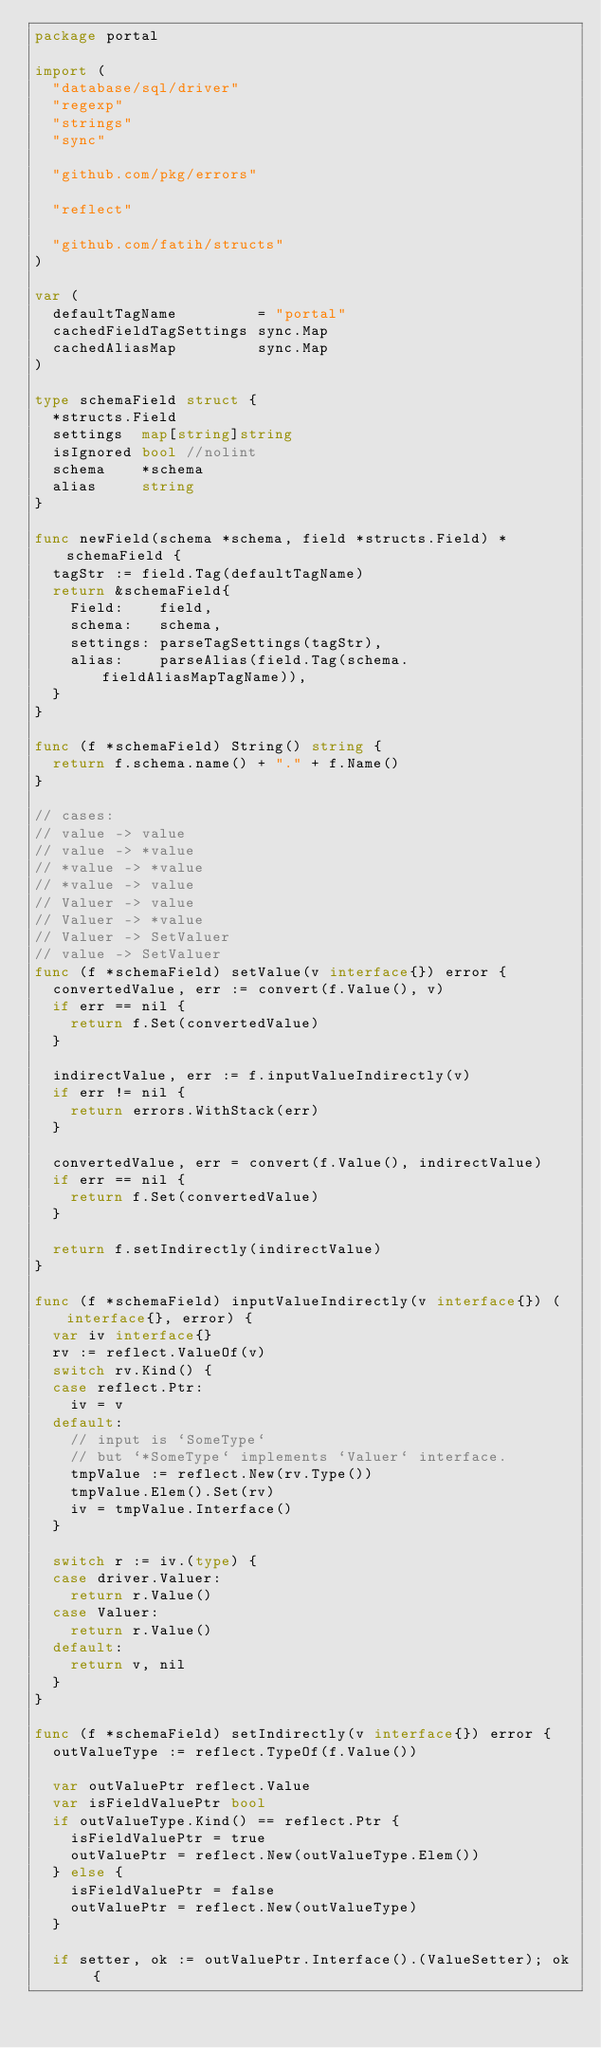<code> <loc_0><loc_0><loc_500><loc_500><_Go_>package portal

import (
	"database/sql/driver"
	"regexp"
	"strings"
	"sync"

	"github.com/pkg/errors"

	"reflect"

	"github.com/fatih/structs"
)

var (
	defaultTagName         = "portal"
	cachedFieldTagSettings sync.Map
	cachedAliasMap         sync.Map
)

type schemaField struct {
	*structs.Field
	settings  map[string]string
	isIgnored bool //nolint
	schema    *schema
	alias     string
}

func newField(schema *schema, field *structs.Field) *schemaField {
	tagStr := field.Tag(defaultTagName)
	return &schemaField{
		Field:    field,
		schema:   schema,
		settings: parseTagSettings(tagStr),
		alias:    parseAlias(field.Tag(schema.fieldAliasMapTagName)),
	}
}

func (f *schemaField) String() string {
	return f.schema.name() + "." + f.Name()
}

// cases:
// value -> value
// value -> *value
// *value -> *value
// *value -> value
// Valuer -> value
// Valuer -> *value
// Valuer -> SetValuer
// value -> SetValuer
func (f *schemaField) setValue(v interface{}) error {
	convertedValue, err := convert(f.Value(), v)
	if err == nil {
		return f.Set(convertedValue)
	}

	indirectValue, err := f.inputValueIndirectly(v)
	if err != nil {
		return errors.WithStack(err)
	}

	convertedValue, err = convert(f.Value(), indirectValue)
	if err == nil {
		return f.Set(convertedValue)
	}

	return f.setIndirectly(indirectValue)
}

func (f *schemaField) inputValueIndirectly(v interface{}) (interface{}, error) {
	var iv interface{}
	rv := reflect.ValueOf(v)
	switch rv.Kind() {
	case reflect.Ptr:
		iv = v
	default:
		// input is `SomeType`
		// but `*SomeType` implements `Valuer` interface.
		tmpValue := reflect.New(rv.Type())
		tmpValue.Elem().Set(rv)
		iv = tmpValue.Interface()
	}

	switch r := iv.(type) {
	case driver.Valuer:
		return r.Value()
	case Valuer:
		return r.Value()
	default:
		return v, nil
	}
}

func (f *schemaField) setIndirectly(v interface{}) error {
	outValueType := reflect.TypeOf(f.Value())

	var outValuePtr reflect.Value
	var isFieldValuePtr bool
	if outValueType.Kind() == reflect.Ptr {
		isFieldValuePtr = true
		outValuePtr = reflect.New(outValueType.Elem())
	} else {
		isFieldValuePtr = false
		outValuePtr = reflect.New(outValueType)
	}

	if setter, ok := outValuePtr.Interface().(ValueSetter); ok {</code> 